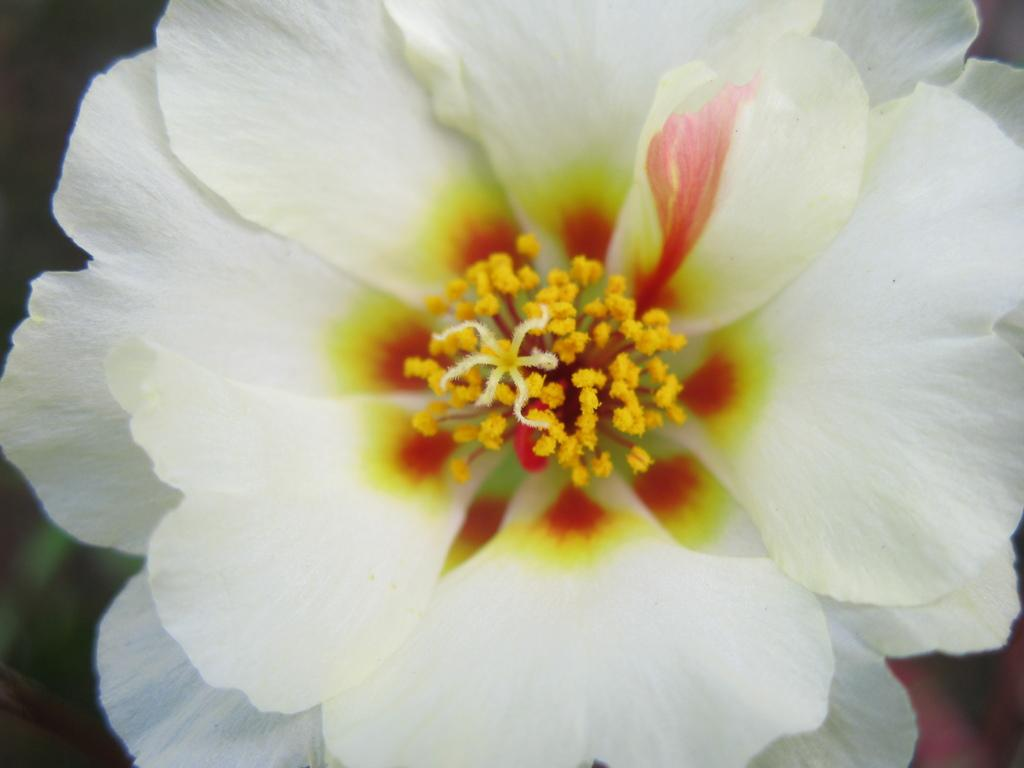What is the main subject of the image? The main subject of the image is a white flower. Can you describe any specific details about the flower? Pollen grains are visible in the image. What type of leather is used to make the pig's bed in the image? There is no leather or pig present in the image; it is a zoom-in of a white flower with pollen grains visible. 